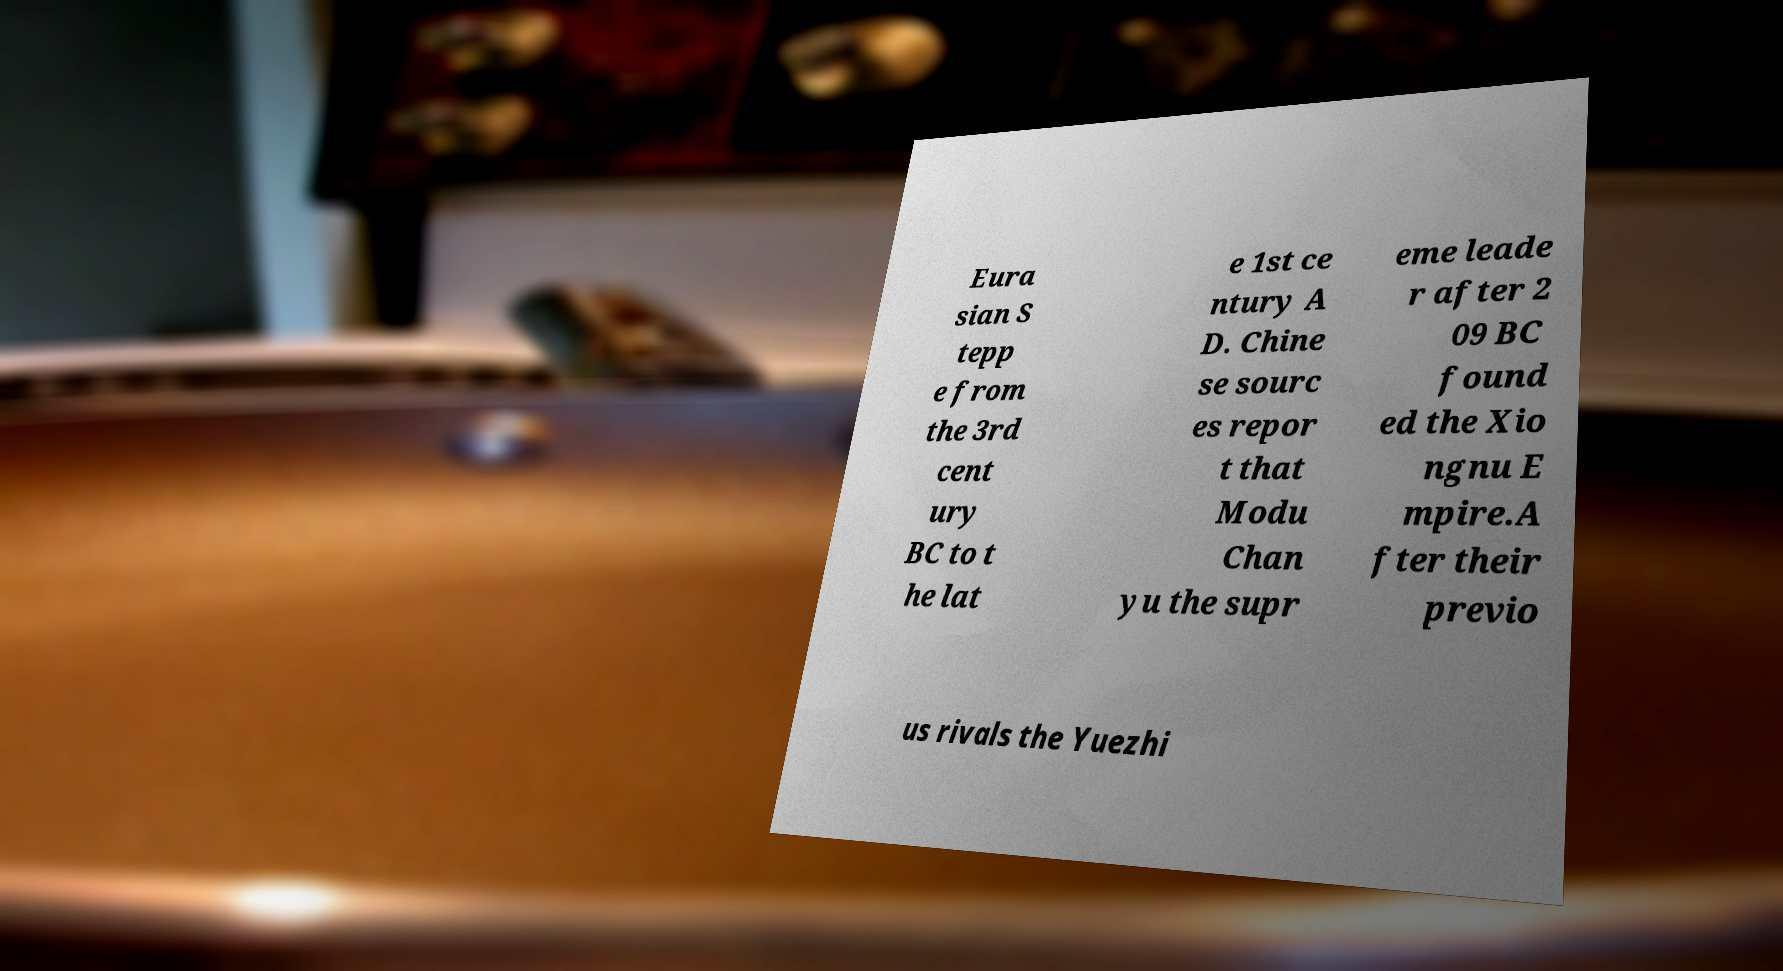What messages or text are displayed in this image? I need them in a readable, typed format. Eura sian S tepp e from the 3rd cent ury BC to t he lat e 1st ce ntury A D. Chine se sourc es repor t that Modu Chan yu the supr eme leade r after 2 09 BC found ed the Xio ngnu E mpire.A fter their previo us rivals the Yuezhi 